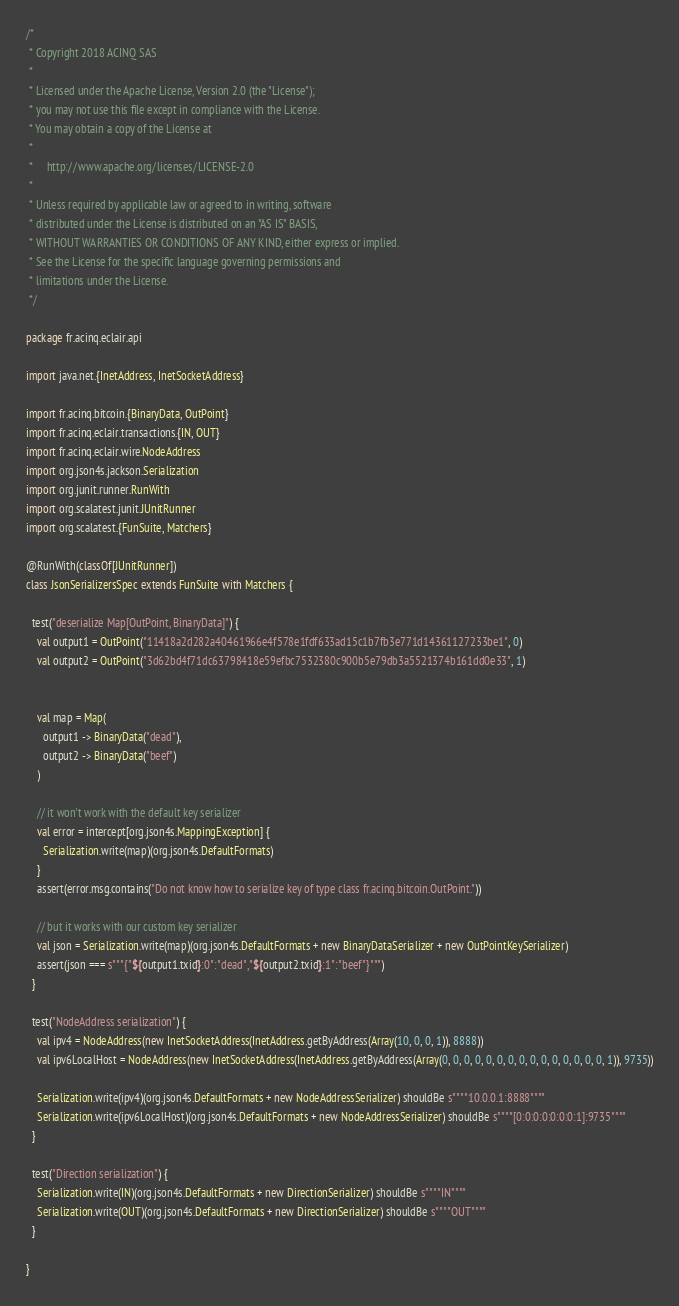Convert code to text. <code><loc_0><loc_0><loc_500><loc_500><_Scala_>/*
 * Copyright 2018 ACINQ SAS
 *
 * Licensed under the Apache License, Version 2.0 (the "License");
 * you may not use this file except in compliance with the License.
 * You may obtain a copy of the License at
 *
 *     http://www.apache.org/licenses/LICENSE-2.0
 *
 * Unless required by applicable law or agreed to in writing, software
 * distributed under the License is distributed on an "AS IS" BASIS,
 * WITHOUT WARRANTIES OR CONDITIONS OF ANY KIND, either express or implied.
 * See the License for the specific language governing permissions and
 * limitations under the License.
 */

package fr.acinq.eclair.api

import java.net.{InetAddress, InetSocketAddress}

import fr.acinq.bitcoin.{BinaryData, OutPoint}
import fr.acinq.eclair.transactions.{IN, OUT}
import fr.acinq.eclair.wire.NodeAddress
import org.json4s.jackson.Serialization
import org.junit.runner.RunWith
import org.scalatest.junit.JUnitRunner
import org.scalatest.{FunSuite, Matchers}

@RunWith(classOf[JUnitRunner])
class JsonSerializersSpec extends FunSuite with Matchers {

  test("deserialize Map[OutPoint, BinaryData]") {
    val output1 = OutPoint("11418a2d282a40461966e4f578e1fdf633ad15c1b7fb3e771d14361127233be1", 0)
    val output2 = OutPoint("3d62bd4f71dc63798418e59efbc7532380c900b5e79db3a5521374b161dd0e33", 1)


    val map = Map(
      output1 -> BinaryData("dead"),
      output2 -> BinaryData("beef")
    )

    // it won't work with the default key serializer
    val error = intercept[org.json4s.MappingException] {
      Serialization.write(map)(org.json4s.DefaultFormats)
    }
    assert(error.msg.contains("Do not know how to serialize key of type class fr.acinq.bitcoin.OutPoint."))

    // but it works with our custom key serializer
    val json = Serialization.write(map)(org.json4s.DefaultFormats + new BinaryDataSerializer + new OutPointKeySerializer)
    assert(json === s"""{"${output1.txid}:0":"dead","${output2.txid}:1":"beef"}""")
  }

  test("NodeAddress serialization") {
    val ipv4 = NodeAddress(new InetSocketAddress(InetAddress.getByAddress(Array(10, 0, 0, 1)), 8888))
    val ipv6LocalHost = NodeAddress(new InetSocketAddress(InetAddress.getByAddress(Array(0, 0, 0, 0, 0, 0, 0, 0, 0, 0, 0, 0, 0, 0, 0, 1)), 9735))

    Serialization.write(ipv4)(org.json4s.DefaultFormats + new NodeAddressSerializer) shouldBe s""""10.0.0.1:8888""""
    Serialization.write(ipv6LocalHost)(org.json4s.DefaultFormats + new NodeAddressSerializer) shouldBe s""""[0:0:0:0:0:0:0:1]:9735""""
  }

  test("Direction serialization") {
    Serialization.write(IN)(org.json4s.DefaultFormats + new DirectionSerializer) shouldBe s""""IN""""
    Serialization.write(OUT)(org.json4s.DefaultFormats + new DirectionSerializer) shouldBe s""""OUT""""
  }

}
</code> 